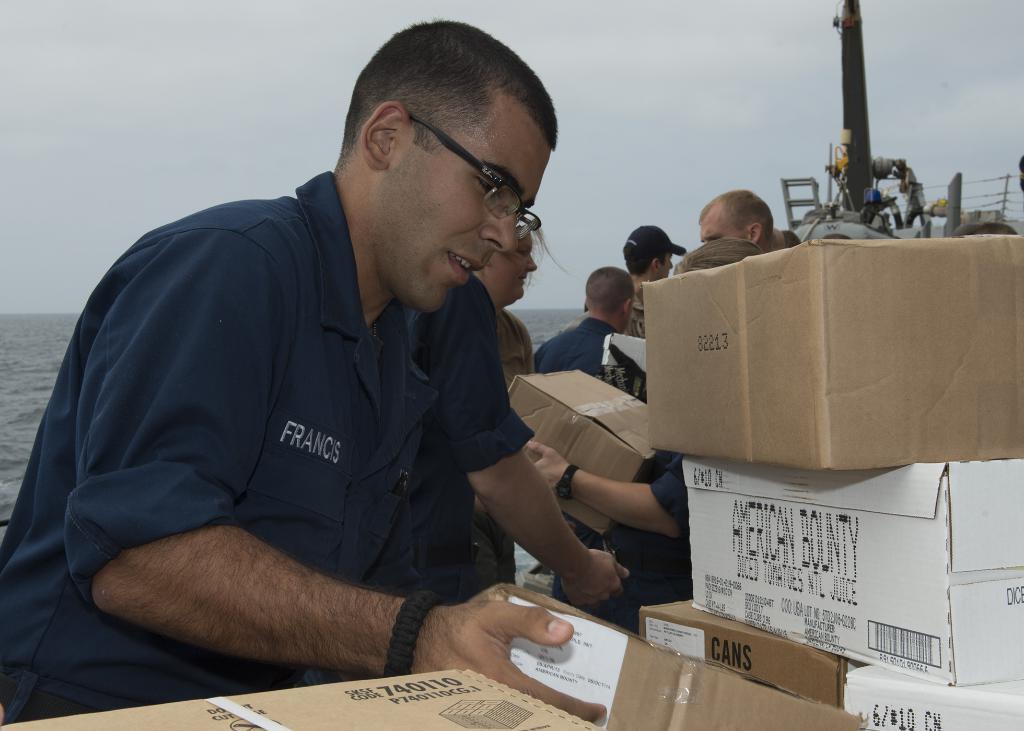Please provide a concise description of this image. There are group of persons standing where few among them are holding wooden boxes in their hands and there are few wooden boxes in the right corner. 